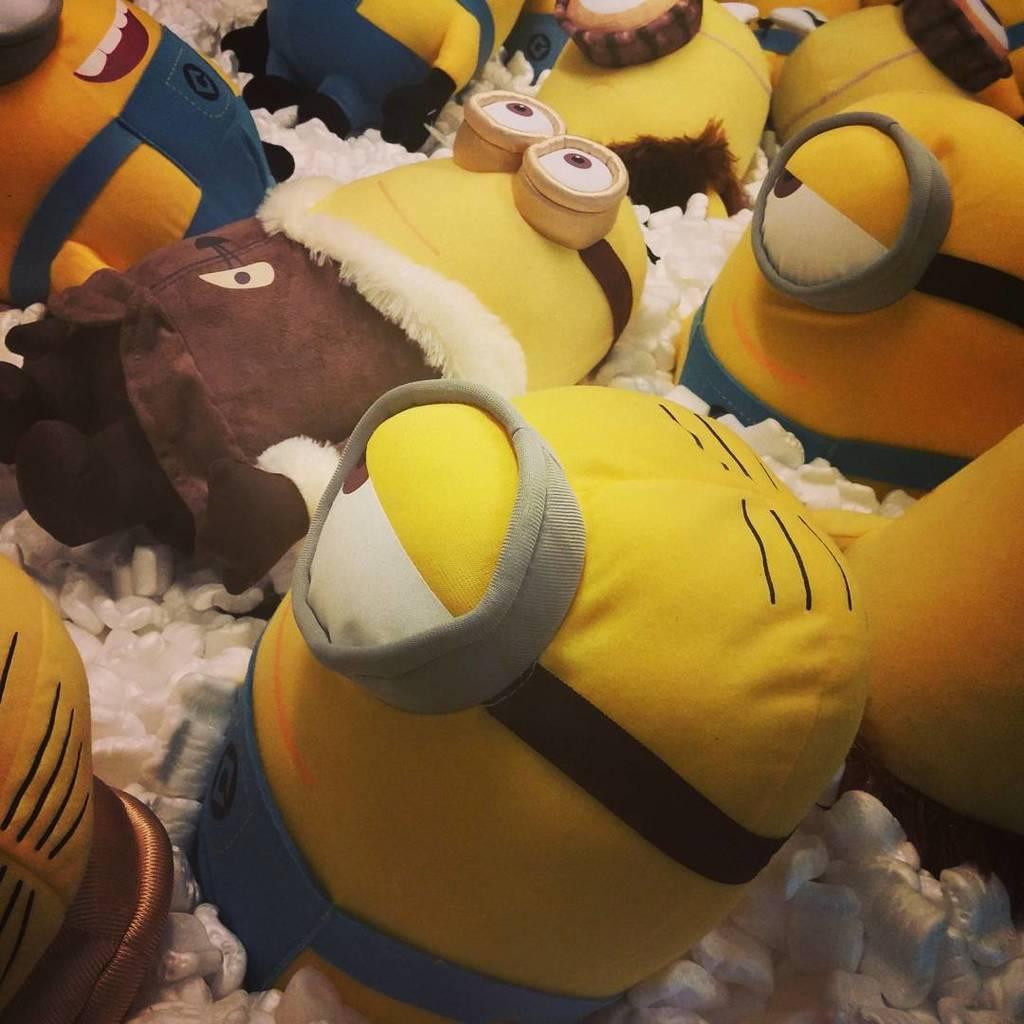In one or two sentences, can you explain what this image depicts? In this image there are toys on the white color objects. 